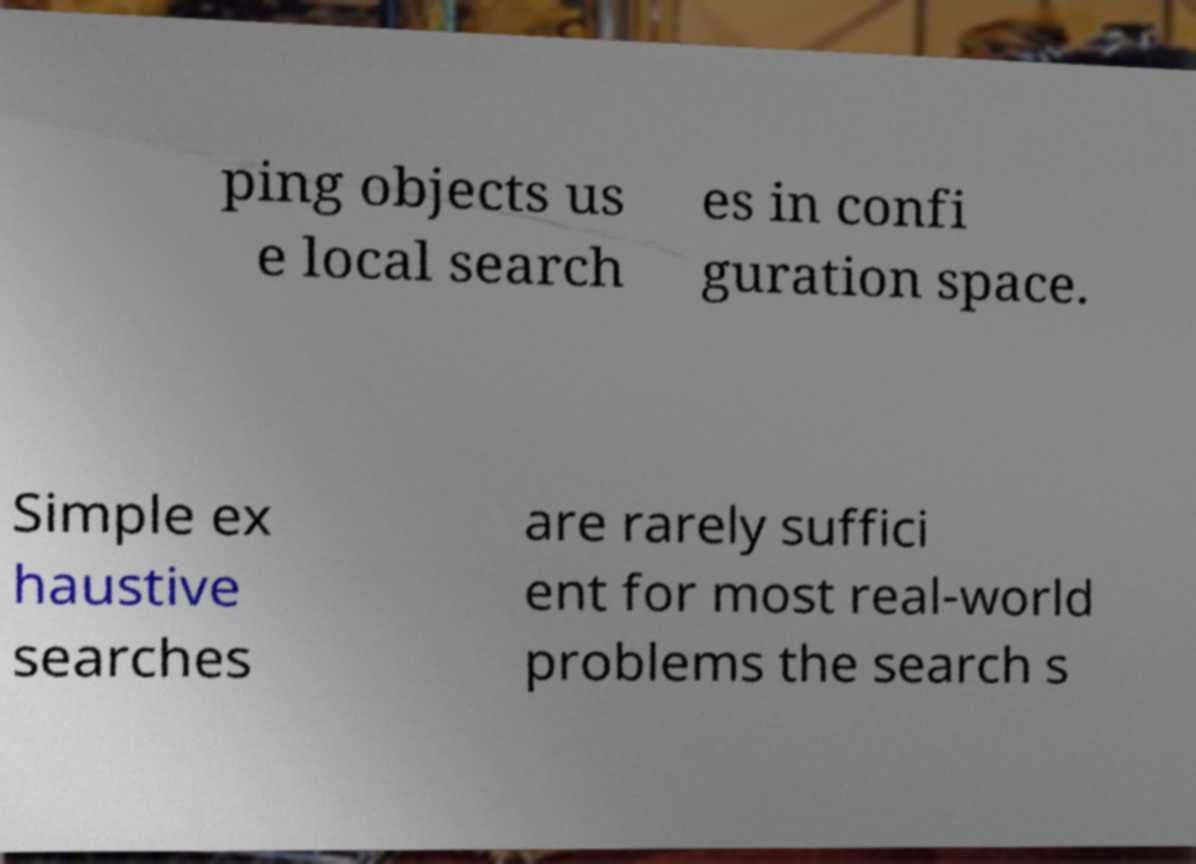Could you extract and type out the text from this image? ping objects us e local search es in confi guration space. Simple ex haustive searches are rarely suffici ent for most real-world problems the search s 